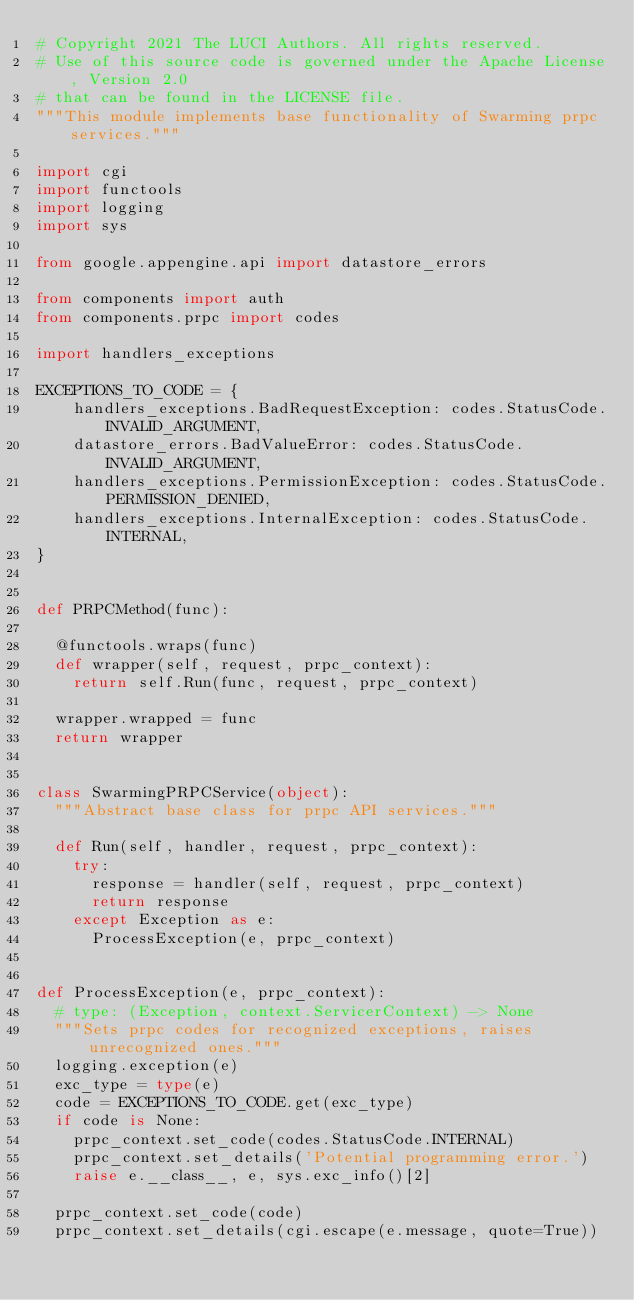<code> <loc_0><loc_0><loc_500><loc_500><_Python_># Copyright 2021 The LUCI Authors. All rights reserved.
# Use of this source code is governed under the Apache License, Version 2.0
# that can be found in the LICENSE file.
"""This module implements base functionality of Swarming prpc services."""

import cgi
import functools
import logging
import sys

from google.appengine.api import datastore_errors

from components import auth
from components.prpc import codes

import handlers_exceptions

EXCEPTIONS_TO_CODE = {
    handlers_exceptions.BadRequestException: codes.StatusCode.INVALID_ARGUMENT,
    datastore_errors.BadValueError: codes.StatusCode.INVALID_ARGUMENT,
    handlers_exceptions.PermissionException: codes.StatusCode.PERMISSION_DENIED,
    handlers_exceptions.InternalException: codes.StatusCode.INTERNAL,
}


def PRPCMethod(func):

  @functools.wraps(func)
  def wrapper(self, request, prpc_context):
    return self.Run(func, request, prpc_context)

  wrapper.wrapped = func
  return wrapper


class SwarmingPRPCService(object):
  """Abstract base class for prpc API services."""

  def Run(self, handler, request, prpc_context):
    try:
      response = handler(self, request, prpc_context)
      return response
    except Exception as e:
      ProcessException(e, prpc_context)


def ProcessException(e, prpc_context):
  # type: (Exception, context.ServicerContext) -> None
  """Sets prpc codes for recognized exceptions, raises unrecognized ones."""
  logging.exception(e)
  exc_type = type(e)
  code = EXCEPTIONS_TO_CODE.get(exc_type)
  if code is None:
    prpc_context.set_code(codes.StatusCode.INTERNAL)
    prpc_context.set_details('Potential programming error.')
    raise e.__class__, e, sys.exc_info()[2]

  prpc_context.set_code(code)
  prpc_context.set_details(cgi.escape(e.message, quote=True))
</code> 